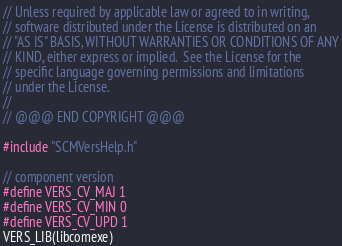Convert code to text. <code><loc_0><loc_0><loc_500><loc_500><_C++_>// Unless required by applicable law or agreed to in writing,
// software distributed under the License is distributed on an
// "AS IS" BASIS, WITHOUT WARRANTIES OR CONDITIONS OF ANY
// KIND, either express or implied.  See the License for the
// specific language governing permissions and limitations
// under the License.
//
// @@@ END COPYRIGHT @@@

#include "SCMVersHelp.h"

// component version
#define VERS_CV_MAJ 1
#define VERS_CV_MIN 0
#define VERS_CV_UPD 1
VERS_LIB(libcomexe)
</code> 